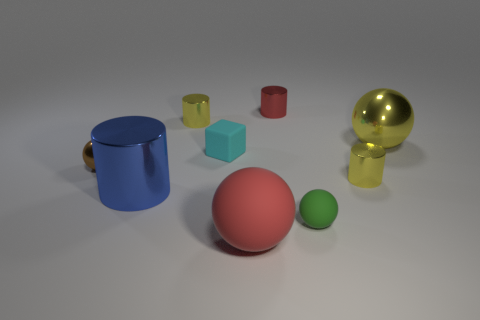What number of other things are the same size as the brown sphere?
Your answer should be very brief. 5. There is a small sphere that is to the right of the big cylinder; is its color the same as the small metal cylinder that is left of the red cylinder?
Your answer should be very brief. No. There is a small shiny thing that is the same shape as the red rubber thing; what color is it?
Make the answer very short. Brown. Is there anything else that is the same shape as the green matte thing?
Keep it short and to the point. Yes. Is the shape of the tiny yellow metal thing behind the brown ball the same as the tiny rubber thing behind the tiny shiny sphere?
Keep it short and to the point. No. Do the cyan matte thing and the yellow cylinder left of the small red shiny cylinder have the same size?
Make the answer very short. Yes. Is the number of big blue cylinders greater than the number of shiny objects?
Make the answer very short. No. Are the small yellow cylinder that is to the right of the big matte ball and the large sphere in front of the tiny green sphere made of the same material?
Your response must be concise. No. What material is the big red object?
Your answer should be very brief. Rubber. Is the number of large matte spheres that are on the right side of the brown metal object greater than the number of yellow rubber cubes?
Provide a succinct answer. Yes. 